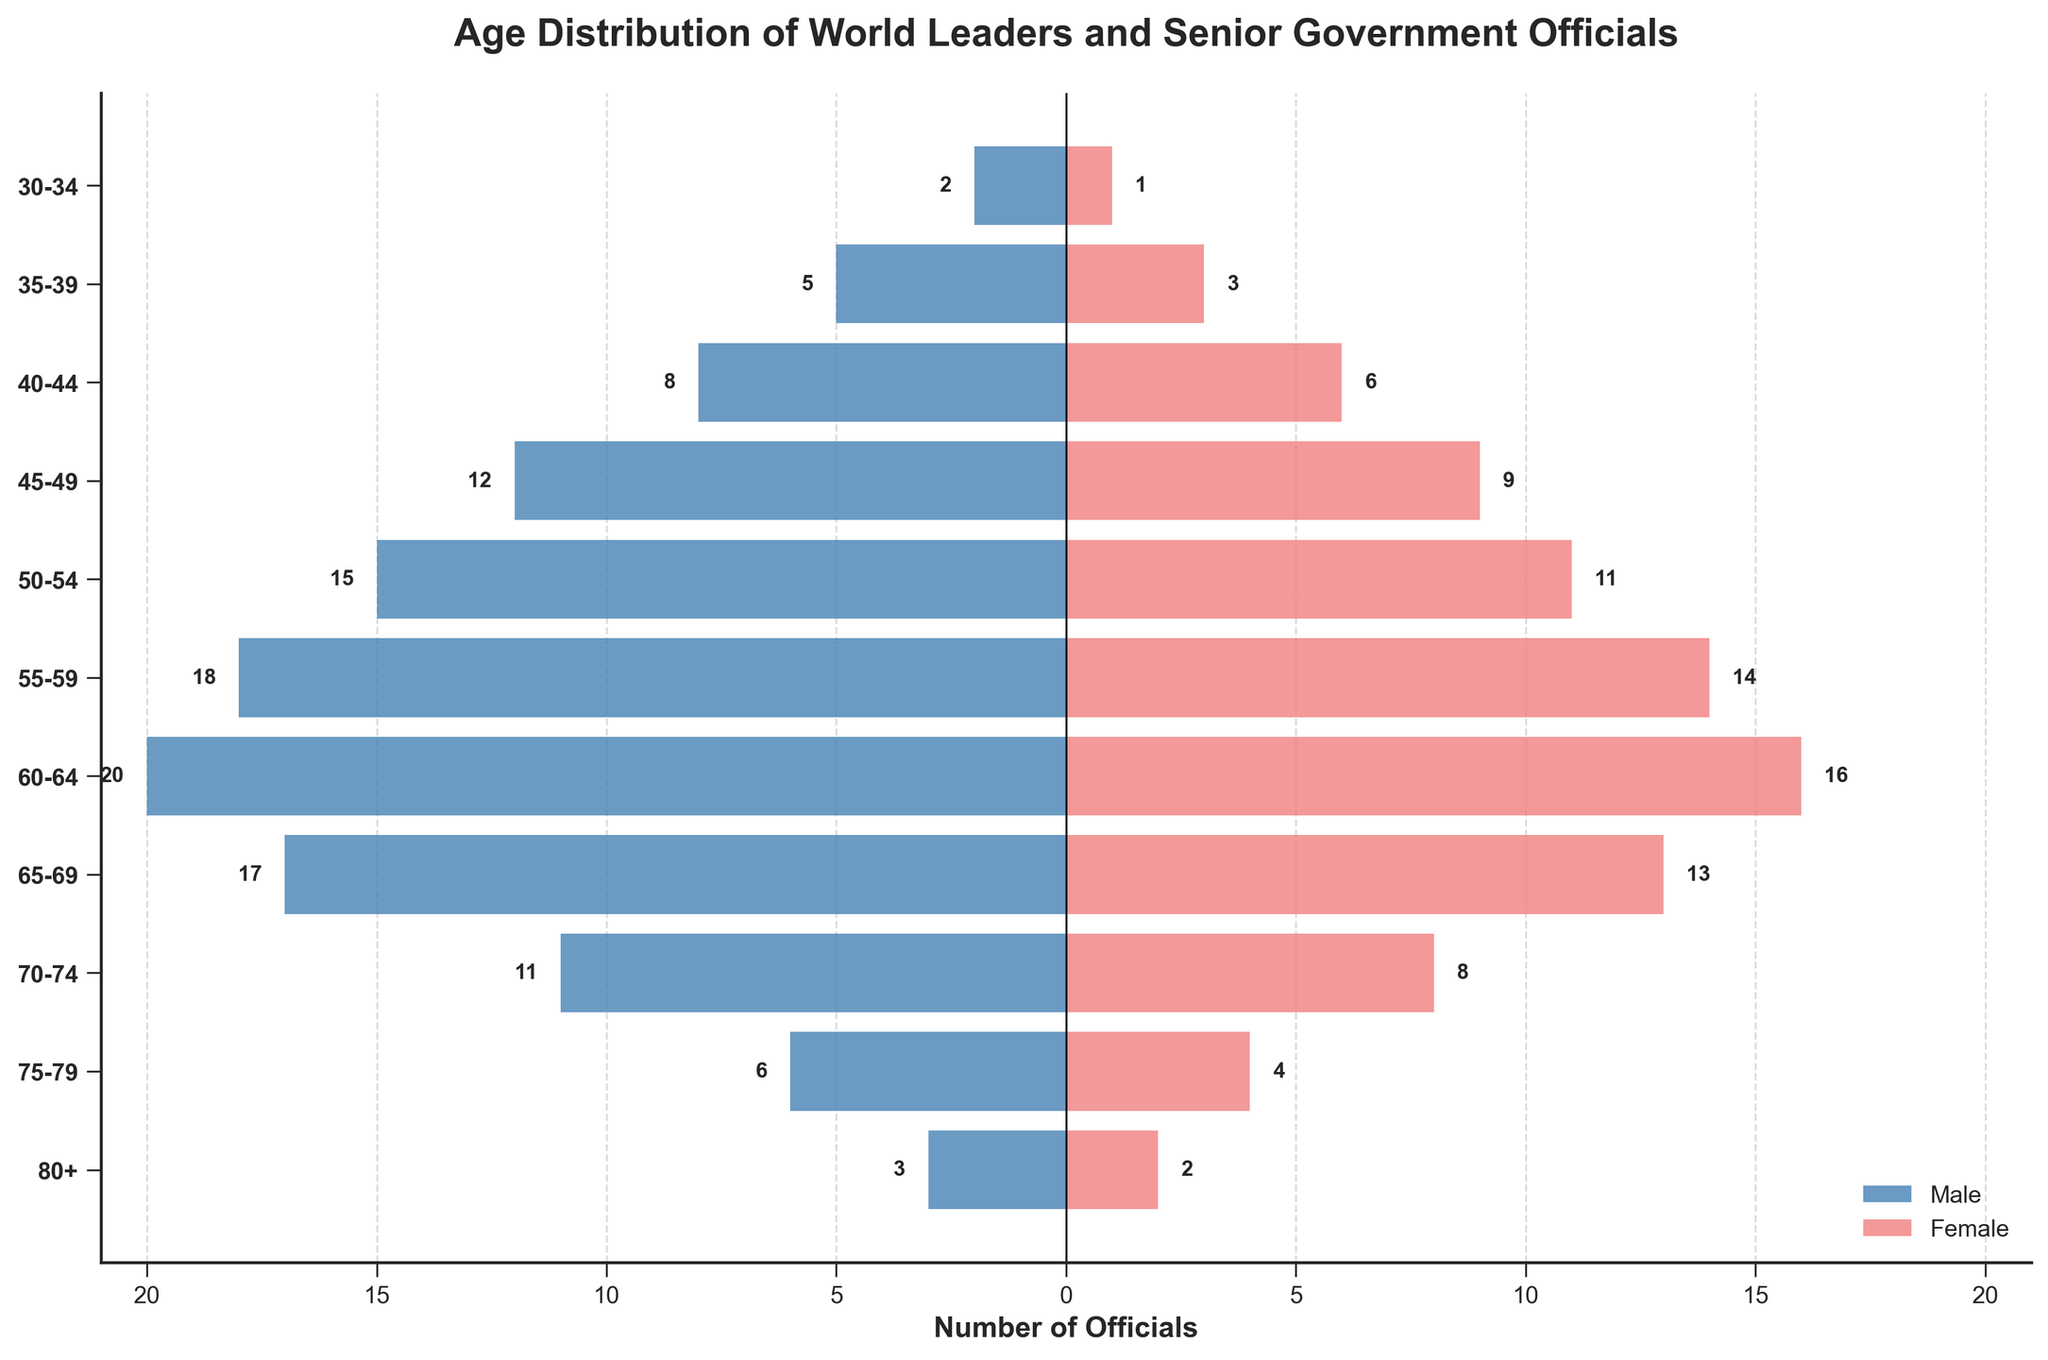Which age group has the highest number of male officials? First, locate the bars on the horizontal axis representing the male officials. Then identify the group with the most negative value, which indicates the highest number of male officials.
Answer: 60-64 Which age group has more female officials: 50-54 or 65-69? Compare the lengths of the bars for females in these age groups. The group with the longer bar has more female officials.
Answer: 50-54 What is the range of ages represented in the chart? The range is determined by the youngest and oldest age groups listed on the vertical axis. Identify the topmost and bottommost labels on the y-axis to find this range.
Answer: 30-80+ How many total officials are there in the 45-49 age group? Count the number of male officials in the 45-49 age group and convert the negative value to positive. Then add this to the number of female officials in the same group.
Answer: 21 Which gender dominates the 70-74 age group? Compare the length of the male and female bars for the 70-74 age group. The gender with the longer bar dominates.
Answer: Male How does the number of officials in the 55-59 age group compare to the 75-79 age group? Determine the sum of male and female officials within both age groups, then compare these totals.
Answer: 55-59 has more officials What is the difference in the number of male and female officials in the 60-64 age group? Identify the values for male and female officials in this age group, convert the male value to positive, and subtract the number of female officials from the number of male officials.
Answer: 4 Which age group has the smallest number of total officials? For each age group, sum the absolute values of the male and female bars and identify the group with the smallest sum.
Answer: 30-34 What trend can you observe about the number of male officials as age increases? Examine the lengths of the male bars from the youngest to the oldest age groups and describe whether they tend to increase, decrease, or fluctuate.
Answer: Increase until 60-64, then decrease How does the representation of females compare to males in the 35-39 age group? Compare the lengths of the bars for males and females in this age group. The relationship will indicate whether females are underrepresented or overrepresented compared to males.
Answer: Underrepresented 